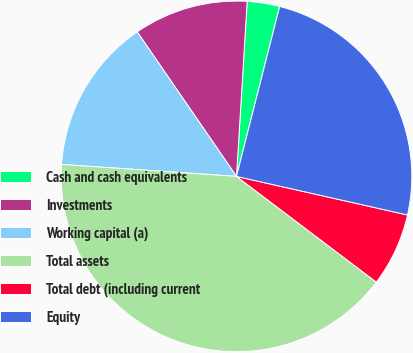<chart> <loc_0><loc_0><loc_500><loc_500><pie_chart><fcel>Cash and cash equivalents<fcel>Investments<fcel>Working capital (a)<fcel>Total assets<fcel>Total debt (including current<fcel>Equity<nl><fcel>2.99%<fcel>10.55%<fcel>14.33%<fcel>40.78%<fcel>6.77%<fcel>24.57%<nl></chart> 